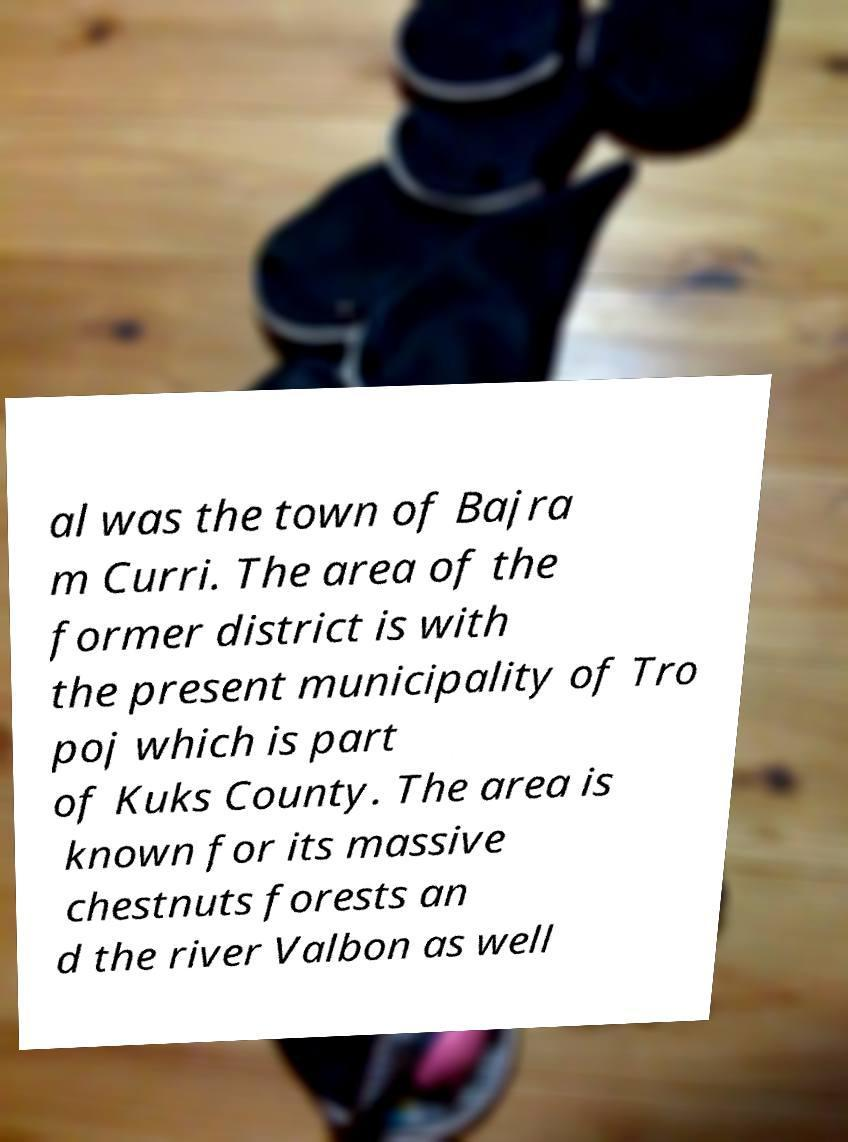Can you accurately transcribe the text from the provided image for me? al was the town of Bajra m Curri. The area of the former district is with the present municipality of Tro poj which is part of Kuks County. The area is known for its massive chestnuts forests an d the river Valbon as well 